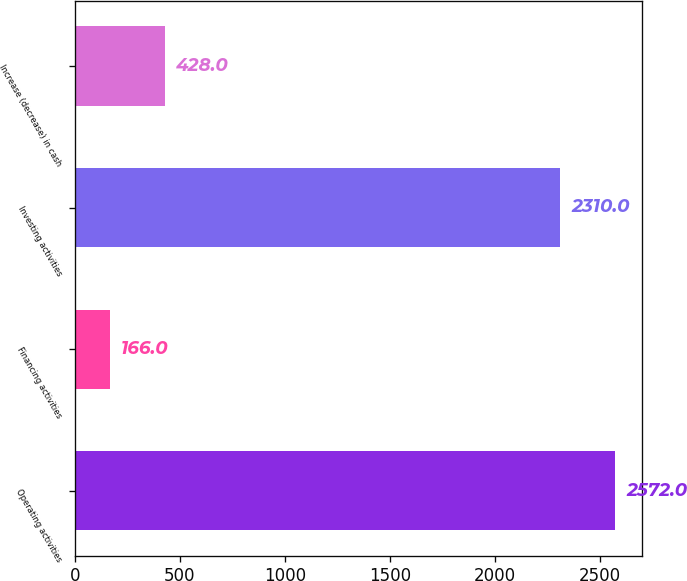Convert chart. <chart><loc_0><loc_0><loc_500><loc_500><bar_chart><fcel>Operating activities<fcel>Financing activities<fcel>Investing activities<fcel>Increase (decrease) in cash<nl><fcel>2572<fcel>166<fcel>2310<fcel>428<nl></chart> 